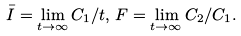Convert formula to latex. <formula><loc_0><loc_0><loc_500><loc_500>\bar { I } = \lim _ { t \rightarrow \infty } C _ { 1 } / t , \, F = \lim _ { t \rightarrow \infty } C _ { 2 } / C _ { 1 } .</formula> 